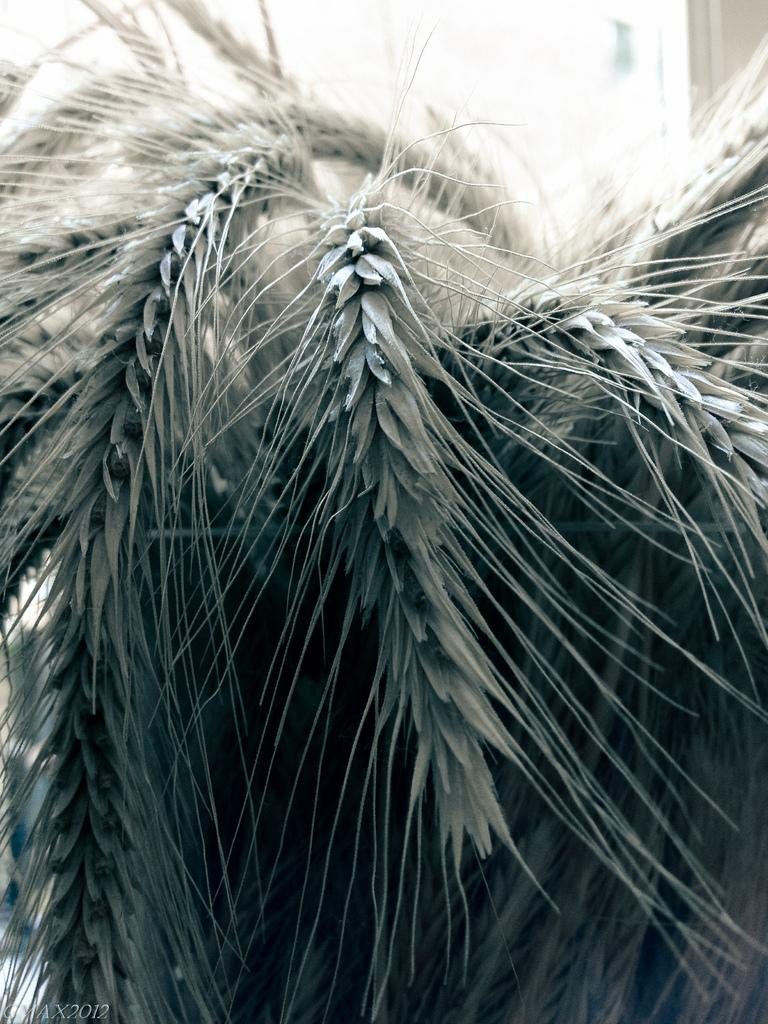What is the main subject of the image? The main subject of the image is a closeup picture of leaves. What type of plant do the leaves belong to? The leaves are from a tree. What type of verse can be seen written on the leaves in the image? There is no verse written on the leaves in the image; it is a closeup picture of leaves from a tree. 